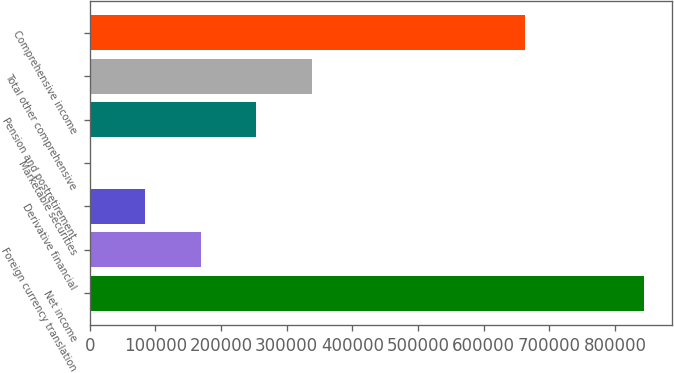Convert chart to OTSL. <chart><loc_0><loc_0><loc_500><loc_500><bar_chart><fcel>Net income<fcel>Foreign currency translation<fcel>Derivative financial<fcel>Marketable securities<fcel>Pension and postretirement<fcel>Total other comprehensive<fcel>Comprehensive income<nl><fcel>844611<fcel>169261<fcel>84842.7<fcel>424<fcel>253680<fcel>338099<fcel>662344<nl></chart> 